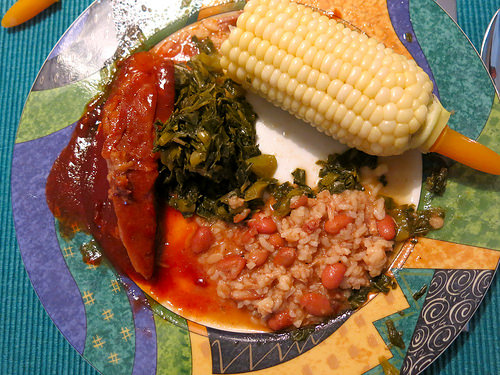<image>
Is the corn cob on the plate? Yes. Looking at the image, I can see the corn cob is positioned on top of the plate, with the plate providing support. Where is the corn in relation to the edge? Is it on the edge? Yes. Looking at the image, I can see the corn is positioned on top of the edge, with the edge providing support. Where is the plate in relation to the corn? Is it under the corn? Yes. The plate is positioned underneath the corn, with the corn above it in the vertical space. Is there a corn above the plate? No. The corn is not positioned above the plate. The vertical arrangement shows a different relationship. 